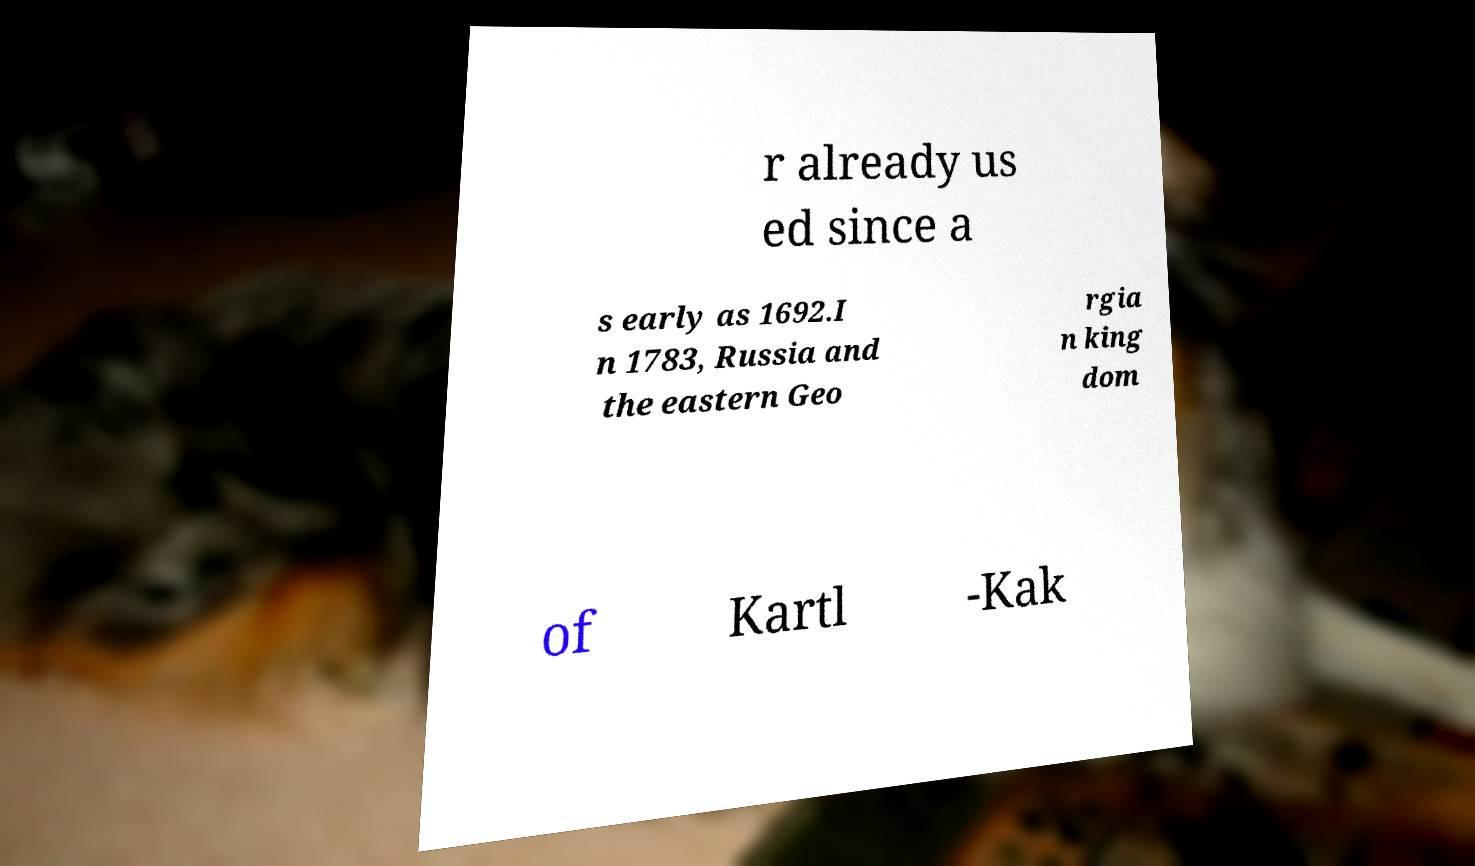There's text embedded in this image that I need extracted. Can you transcribe it verbatim? r already us ed since a s early as 1692.I n 1783, Russia and the eastern Geo rgia n king dom of Kartl -Kak 